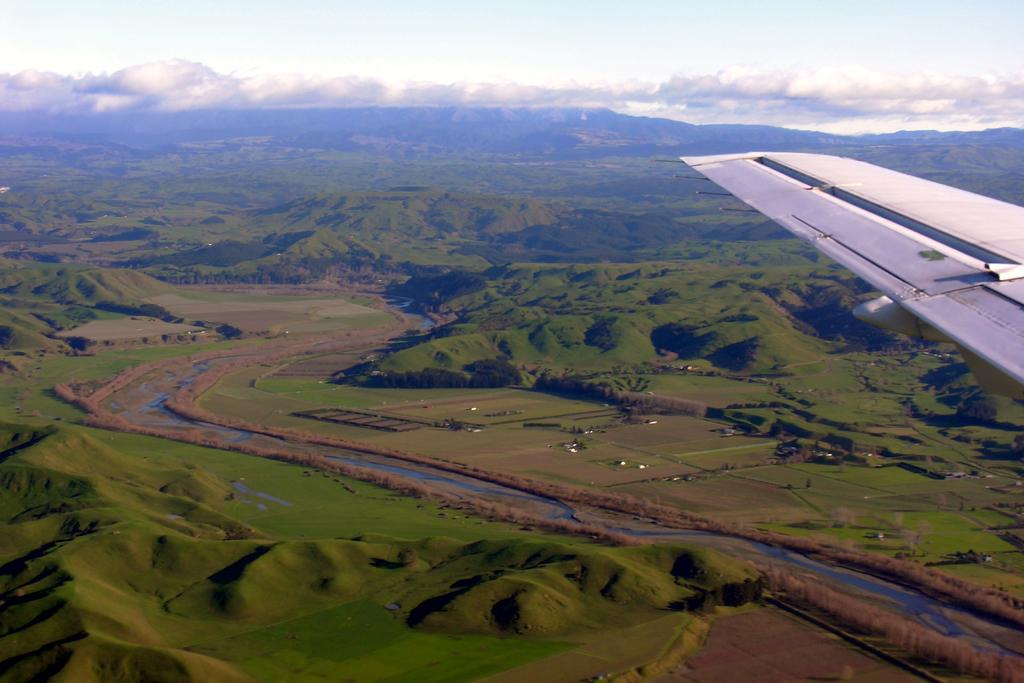What is the main subject of the image? The main subject of the image is an airplane. What is the airplane doing in the image? The airplane is flying in the image. What type of terrain can be seen in the image? There is grass visible in the image. How would you describe the weather based on the image? The sky is cloudy in the image. Can you see your friend reading books at the station in the image? There is no friend, books, or station present in the image; it features an airplane flying over grass with a cloudy sky. 